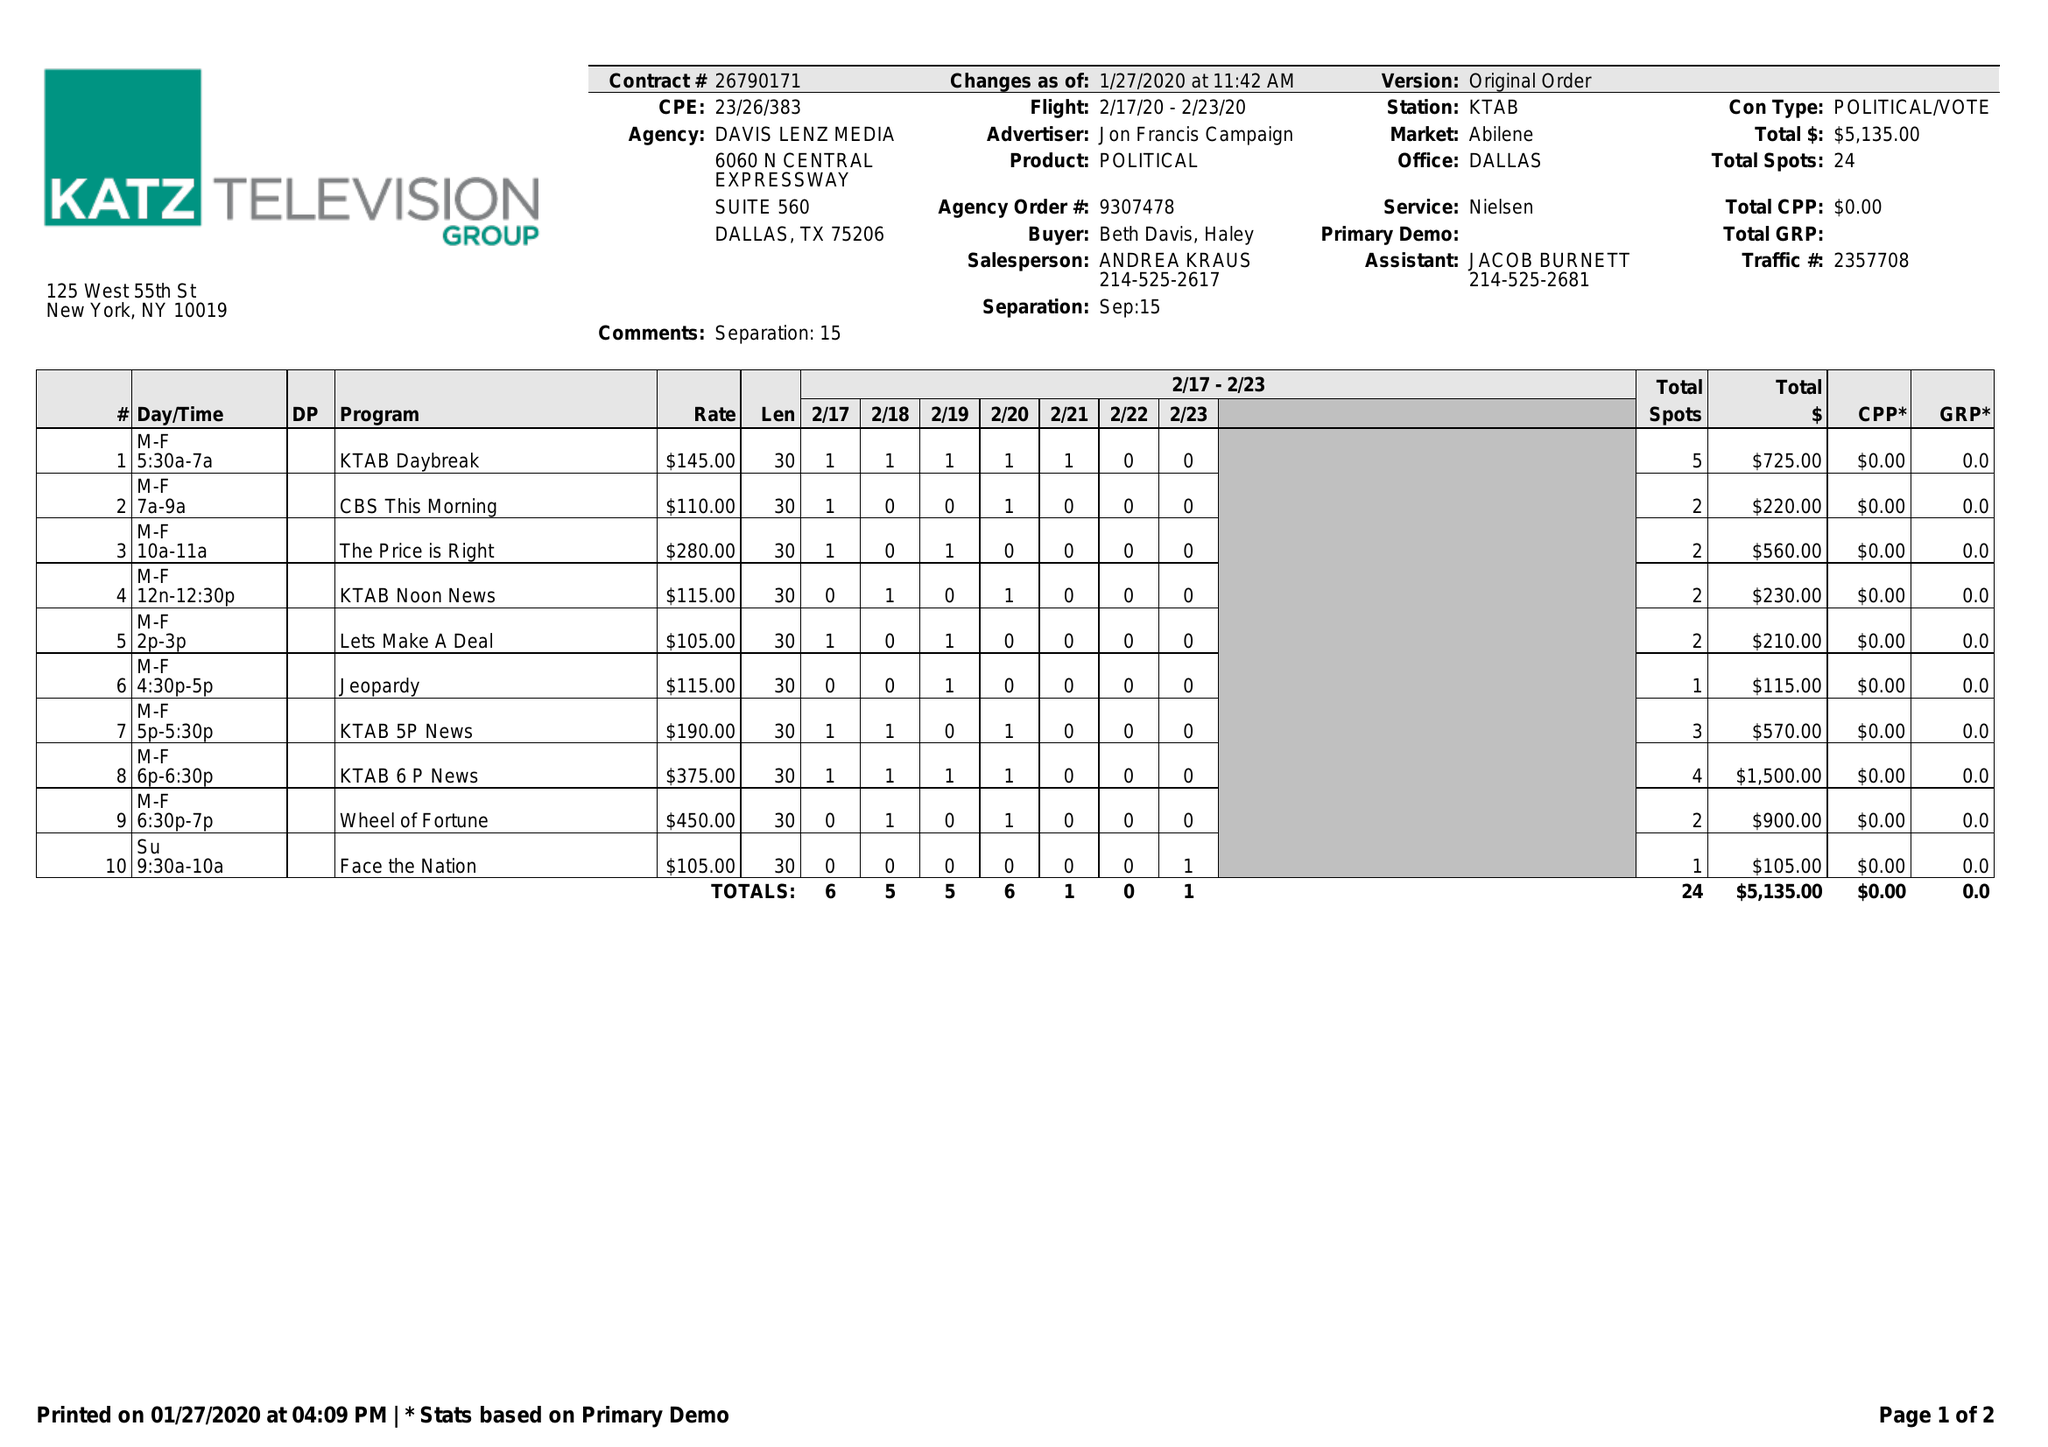What is the value for the flight_from?
Answer the question using a single word or phrase. 02/17/20 